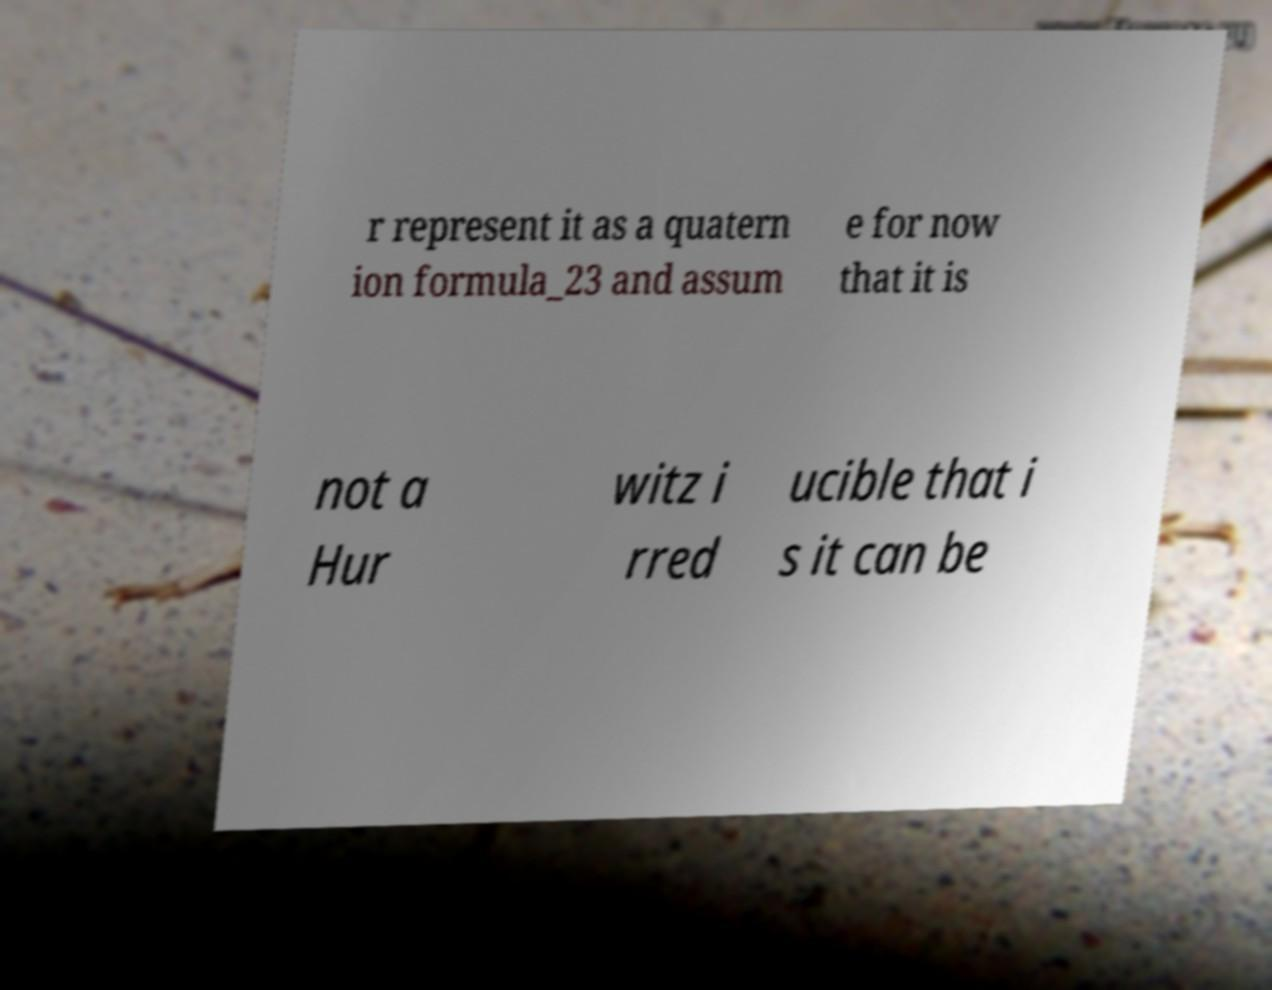Please identify and transcribe the text found in this image. r represent it as a quatern ion formula_23 and assum e for now that it is not a Hur witz i rred ucible that i s it can be 